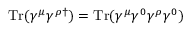Convert formula to latex. <formula><loc_0><loc_0><loc_500><loc_500>T r ( \gamma ^ { \mu } \gamma ^ { \rho \dagger } ) = T r ( \gamma ^ { \mu } \gamma ^ { 0 } \gamma ^ { \rho } \gamma ^ { 0 } )</formula> 